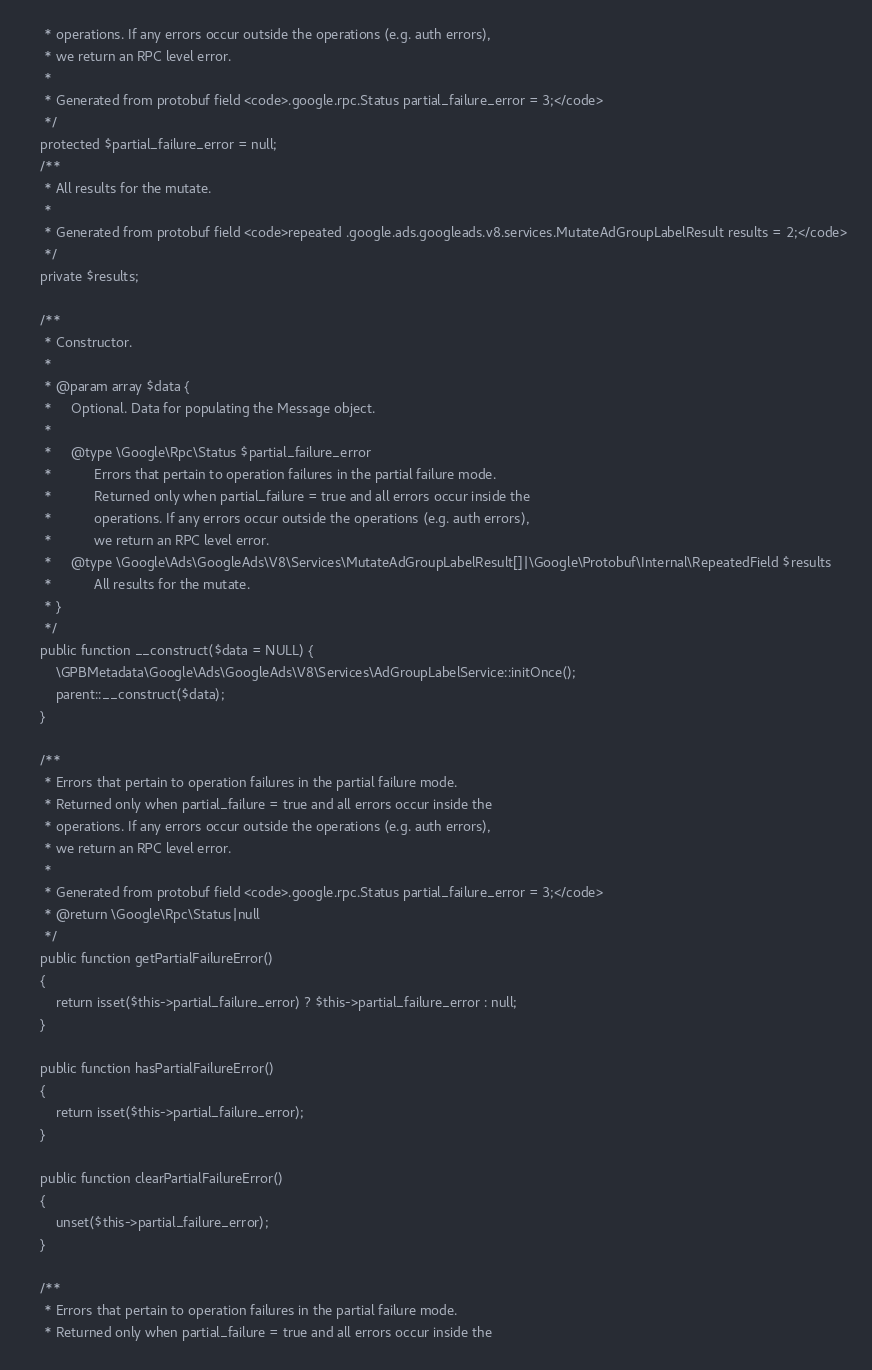<code> <loc_0><loc_0><loc_500><loc_500><_PHP_>     * operations. If any errors occur outside the operations (e.g. auth errors),
     * we return an RPC level error.
     *
     * Generated from protobuf field <code>.google.rpc.Status partial_failure_error = 3;</code>
     */
    protected $partial_failure_error = null;
    /**
     * All results for the mutate.
     *
     * Generated from protobuf field <code>repeated .google.ads.googleads.v8.services.MutateAdGroupLabelResult results = 2;</code>
     */
    private $results;

    /**
     * Constructor.
     *
     * @param array $data {
     *     Optional. Data for populating the Message object.
     *
     *     @type \Google\Rpc\Status $partial_failure_error
     *           Errors that pertain to operation failures in the partial failure mode.
     *           Returned only when partial_failure = true and all errors occur inside the
     *           operations. If any errors occur outside the operations (e.g. auth errors),
     *           we return an RPC level error.
     *     @type \Google\Ads\GoogleAds\V8\Services\MutateAdGroupLabelResult[]|\Google\Protobuf\Internal\RepeatedField $results
     *           All results for the mutate.
     * }
     */
    public function __construct($data = NULL) {
        \GPBMetadata\Google\Ads\GoogleAds\V8\Services\AdGroupLabelService::initOnce();
        parent::__construct($data);
    }

    /**
     * Errors that pertain to operation failures in the partial failure mode.
     * Returned only when partial_failure = true and all errors occur inside the
     * operations. If any errors occur outside the operations (e.g. auth errors),
     * we return an RPC level error.
     *
     * Generated from protobuf field <code>.google.rpc.Status partial_failure_error = 3;</code>
     * @return \Google\Rpc\Status|null
     */
    public function getPartialFailureError()
    {
        return isset($this->partial_failure_error) ? $this->partial_failure_error : null;
    }

    public function hasPartialFailureError()
    {
        return isset($this->partial_failure_error);
    }

    public function clearPartialFailureError()
    {
        unset($this->partial_failure_error);
    }

    /**
     * Errors that pertain to operation failures in the partial failure mode.
     * Returned only when partial_failure = true and all errors occur inside the</code> 